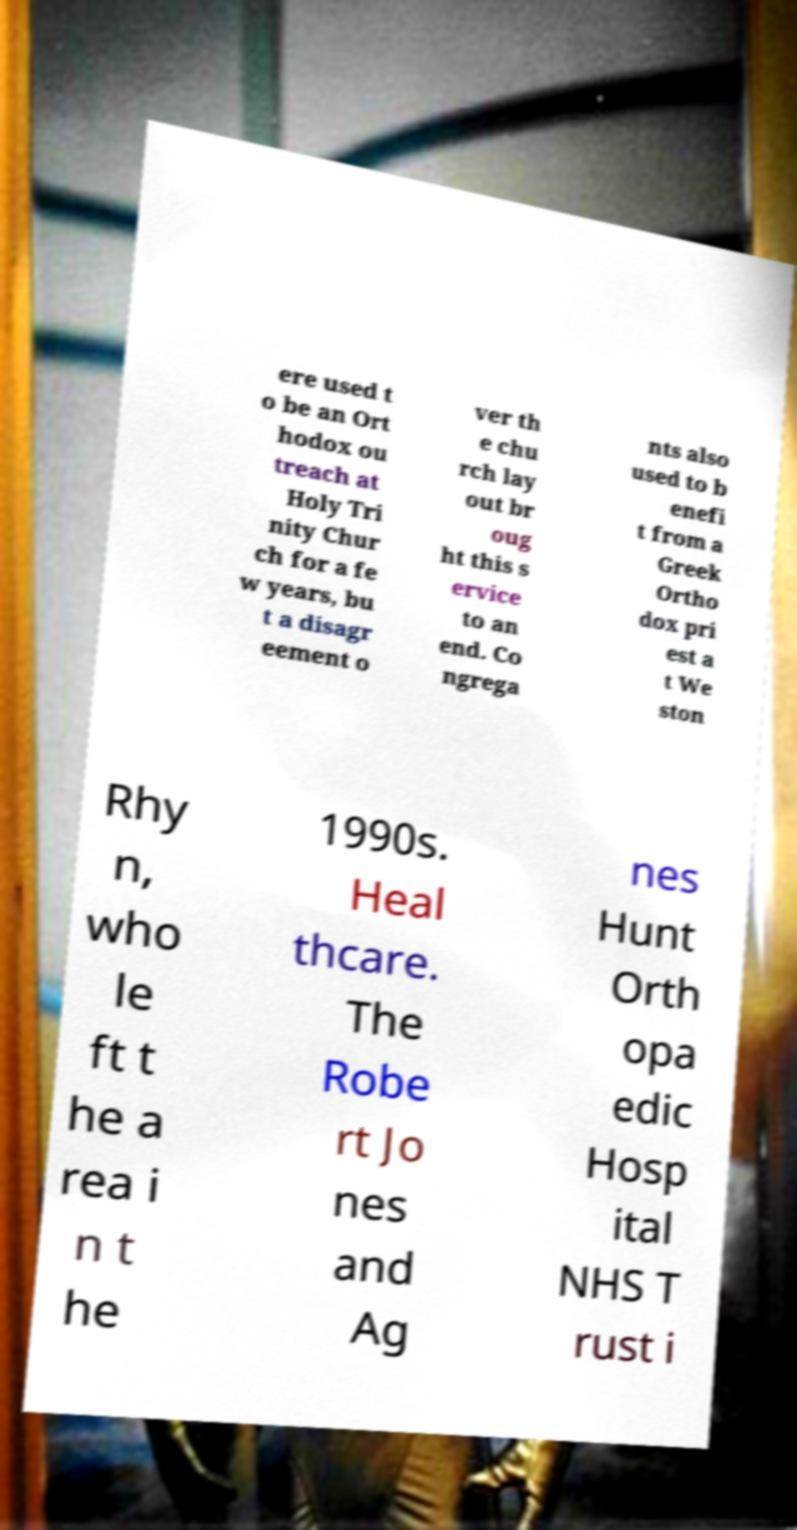Could you assist in decoding the text presented in this image and type it out clearly? ere used t o be an Ort hodox ou treach at Holy Tri nity Chur ch for a fe w years, bu t a disagr eement o ver th e chu rch lay out br oug ht this s ervice to an end. Co ngrega nts also used to b enefi t from a Greek Ortho dox pri est a t We ston Rhy n, who le ft t he a rea i n t he 1990s. Heal thcare. The Robe rt Jo nes and Ag nes Hunt Orth opa edic Hosp ital NHS T rust i 